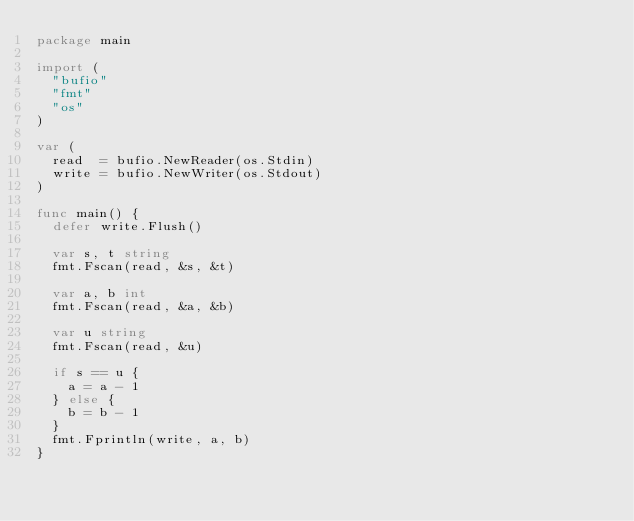Convert code to text. <code><loc_0><loc_0><loc_500><loc_500><_Go_>package main

import (
	"bufio"
	"fmt"
	"os"
)

var (
	read  = bufio.NewReader(os.Stdin)
	write = bufio.NewWriter(os.Stdout)
)

func main() {
	defer write.Flush()

	var s, t string
	fmt.Fscan(read, &s, &t)

	var a, b int
	fmt.Fscan(read, &a, &b)

	var u string
	fmt.Fscan(read, &u)

	if s == u {
		a = a - 1
	} else {
		b = b - 1
	}
	fmt.Fprintln(write, a, b)
}
</code> 